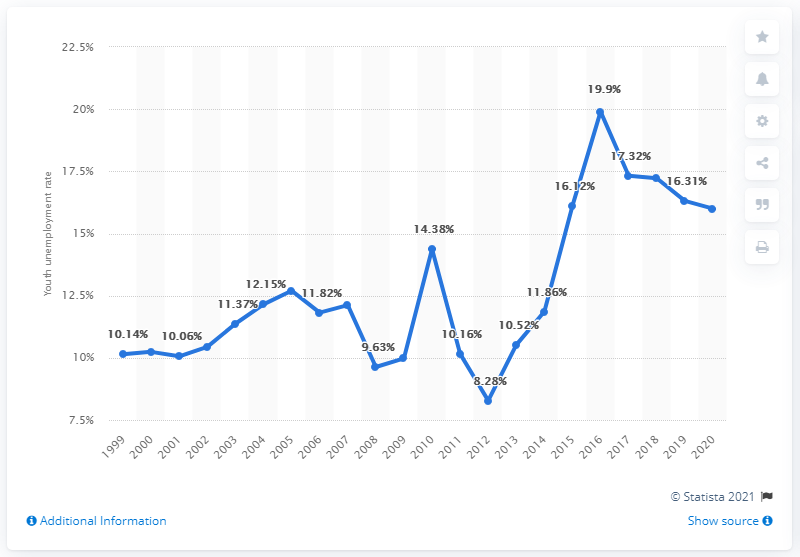Specify some key components in this picture. In 2020, the youth unemployment rate in Mongolia was reported to be 16%. 